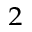<formula> <loc_0><loc_0><loc_500><loc_500>^ { 2 }</formula> 